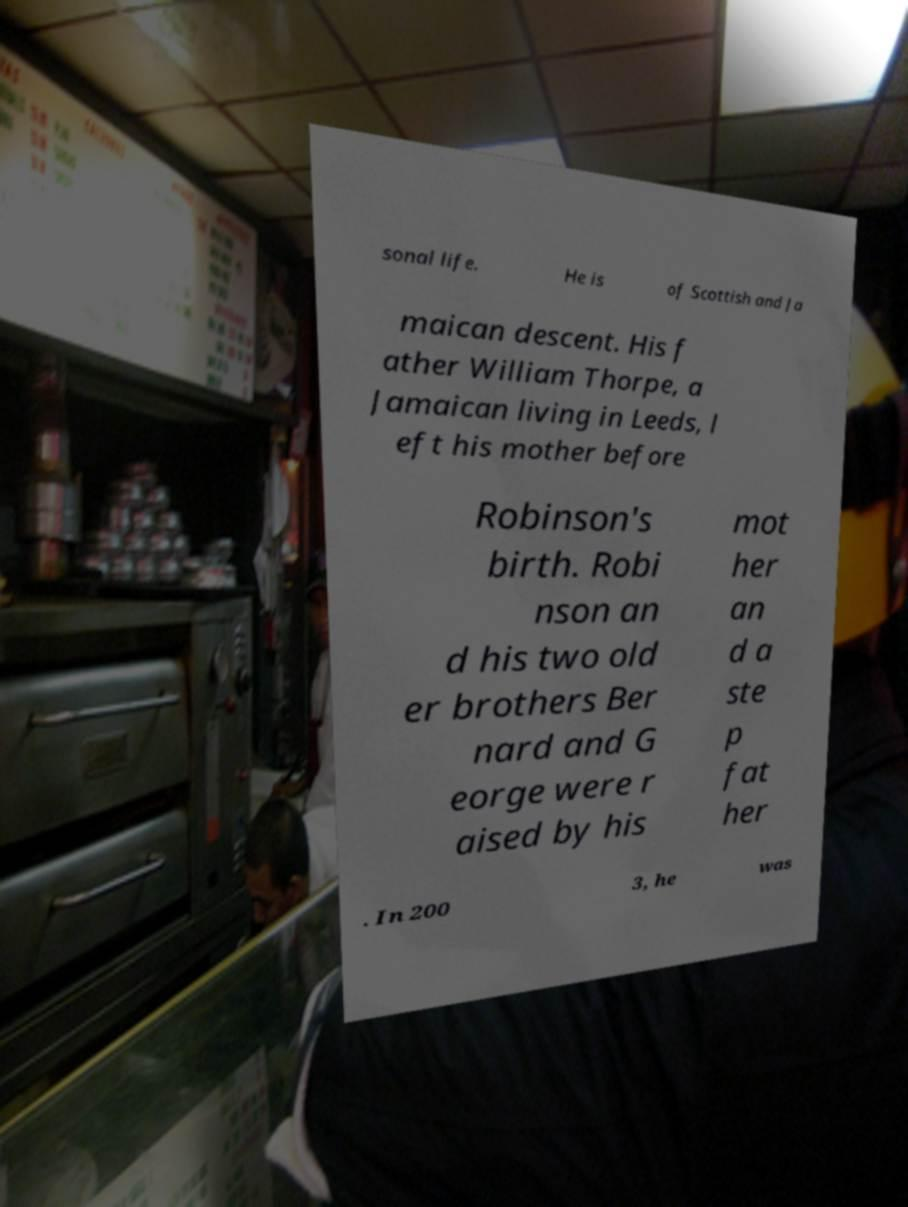Can you accurately transcribe the text from the provided image for me? sonal life. He is of Scottish and Ja maican descent. His f ather William Thorpe, a Jamaican living in Leeds, l eft his mother before Robinson's birth. Robi nson an d his two old er brothers Ber nard and G eorge were r aised by his mot her an d a ste p fat her . In 200 3, he was 